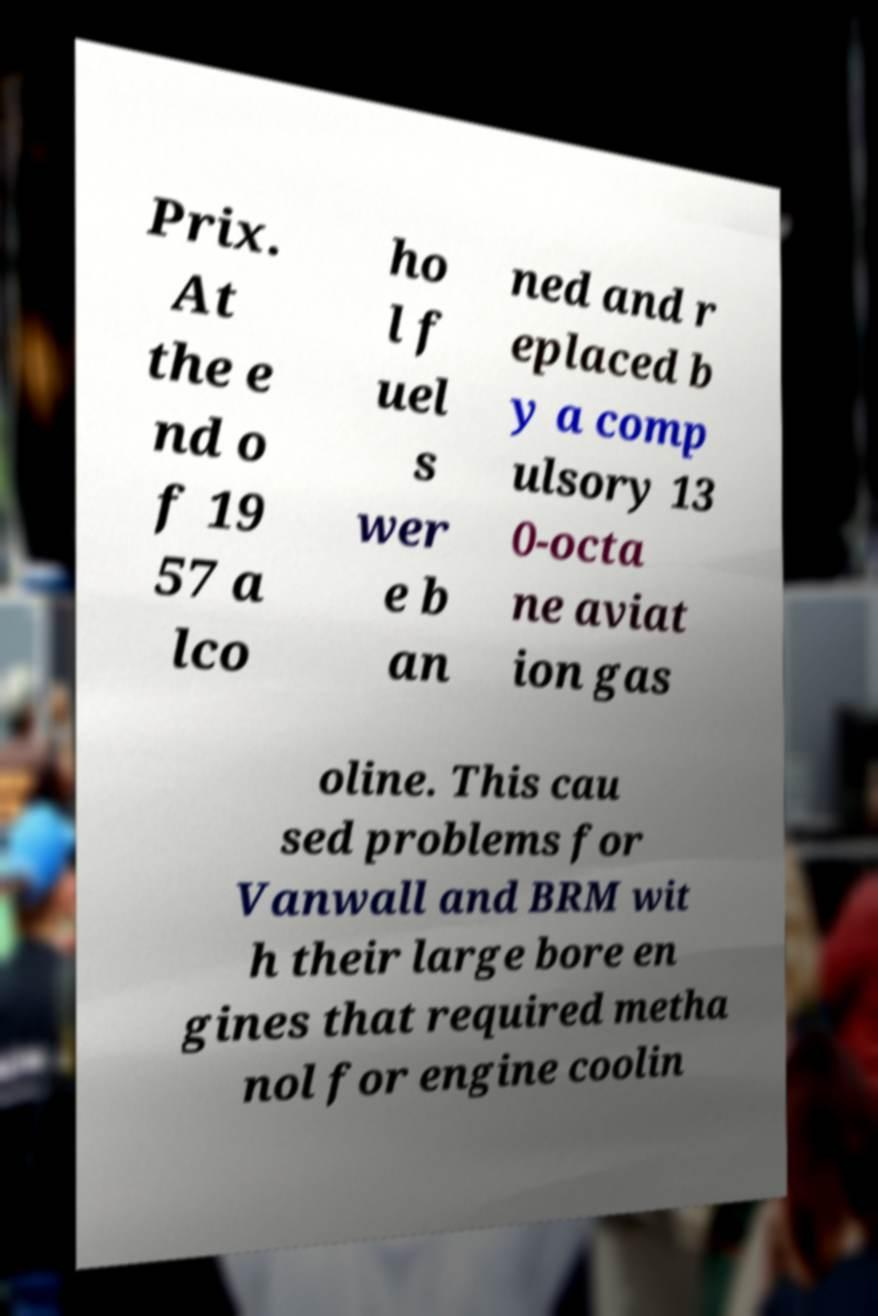Can you accurately transcribe the text from the provided image for me? Prix. At the e nd o f 19 57 a lco ho l f uel s wer e b an ned and r eplaced b y a comp ulsory 13 0-octa ne aviat ion gas oline. This cau sed problems for Vanwall and BRM wit h their large bore en gines that required metha nol for engine coolin 